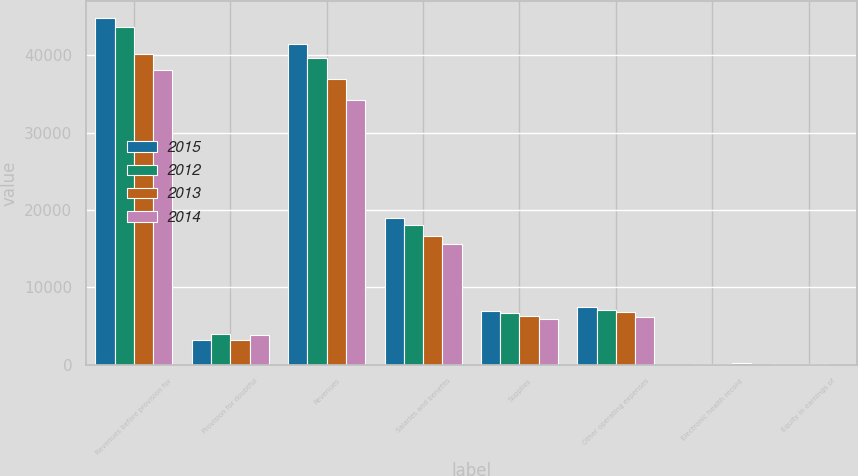Convert chart to OTSL. <chart><loc_0><loc_0><loc_500><loc_500><stacked_bar_chart><ecel><fcel>Revenues before provision for<fcel>Provision for doubtful<fcel>Revenues<fcel>Salaries and benefits<fcel>Supplies<fcel>Other operating expenses<fcel>Electronic health record<fcel>Equity in earnings of<nl><fcel>2015<fcel>44747<fcel>3257<fcel>41490<fcel>18897<fcel>6933<fcel>7508<fcel>12<fcel>54<nl><fcel>2012<fcel>43591<fcel>3913<fcel>39678<fcel>18115<fcel>6638<fcel>7103<fcel>47<fcel>46<nl><fcel>2013<fcel>40087<fcel>3169<fcel>36918<fcel>16641<fcel>6262<fcel>6755<fcel>125<fcel>43<nl><fcel>2014<fcel>38040<fcel>3858<fcel>34182<fcel>15646<fcel>5970<fcel>6237<fcel>216<fcel>29<nl></chart> 